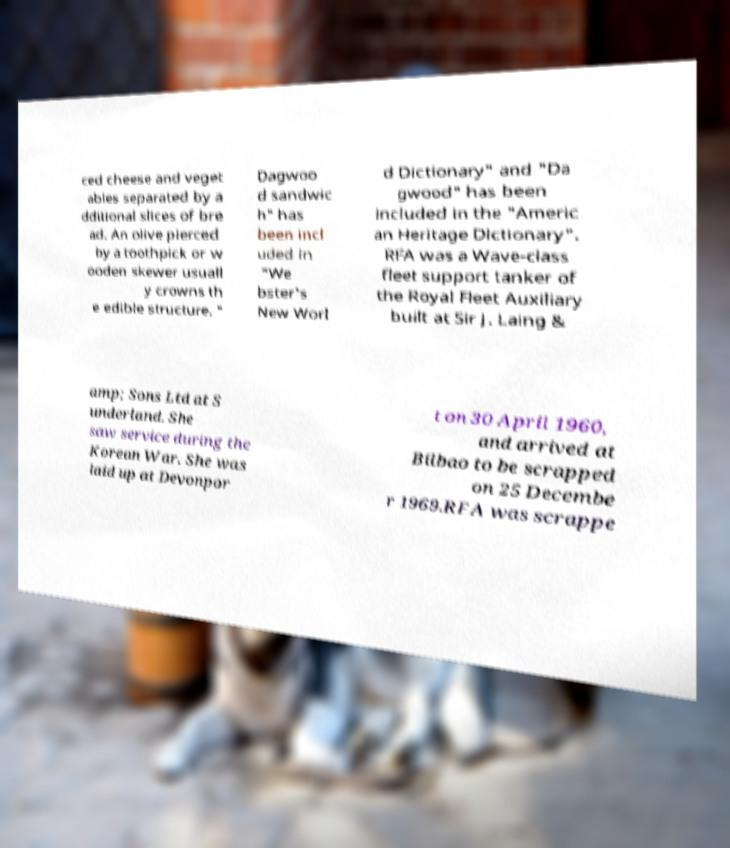For documentation purposes, I need the text within this image transcribed. Could you provide that? ced cheese and veget ables separated by a dditional slices of bre ad. An olive pierced by a toothpick or w ooden skewer usuall y crowns th e edible structure. " Dagwoo d sandwic h" has been incl uded in "We bster's New Worl d Dictionary" and "Da gwood" has been included in the "Americ an Heritage Dictionary". RFA was a Wave-class fleet support tanker of the Royal Fleet Auxiliary built at Sir J. Laing & amp; Sons Ltd at S underland. She saw service during the Korean War. She was laid up at Devonpor t on 30 April 1960, and arrived at Bilbao to be scrapped on 25 Decembe r 1969.RFA was scrappe 